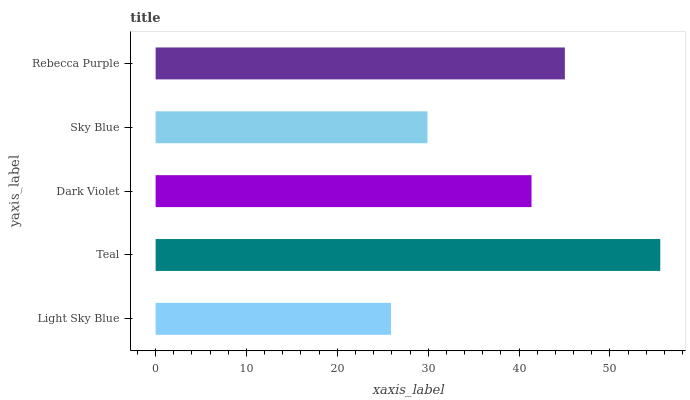Is Light Sky Blue the minimum?
Answer yes or no. Yes. Is Teal the maximum?
Answer yes or no. Yes. Is Dark Violet the minimum?
Answer yes or no. No. Is Dark Violet the maximum?
Answer yes or no. No. Is Teal greater than Dark Violet?
Answer yes or no. Yes. Is Dark Violet less than Teal?
Answer yes or no. Yes. Is Dark Violet greater than Teal?
Answer yes or no. No. Is Teal less than Dark Violet?
Answer yes or no. No. Is Dark Violet the high median?
Answer yes or no. Yes. Is Dark Violet the low median?
Answer yes or no. Yes. Is Teal the high median?
Answer yes or no. No. Is Light Sky Blue the low median?
Answer yes or no. No. 